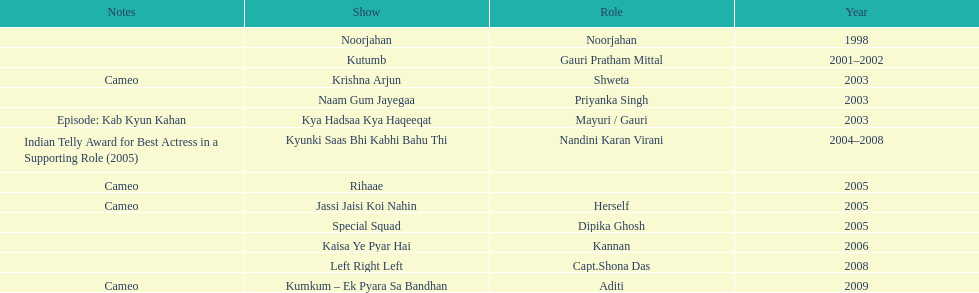What was the most years a show lasted? 4. 